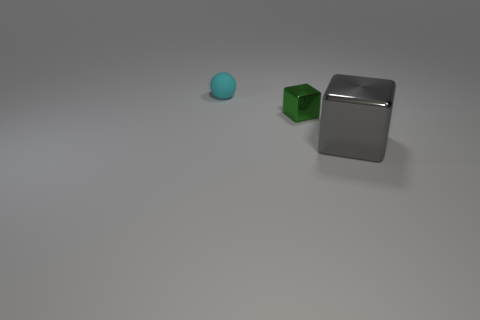Add 1 red rubber cubes. How many objects exist? 4 Add 1 gray shiny things. How many gray shiny things are left? 2 Add 3 large red rubber cylinders. How many large red rubber cylinders exist? 3 Subtract all gray cubes. How many cubes are left? 1 Subtract 0 brown balls. How many objects are left? 3 Subtract all blocks. How many objects are left? 1 Subtract 1 spheres. How many spheres are left? 0 Subtract all gray spheres. Subtract all yellow cylinders. How many spheres are left? 1 Subtract all yellow spheres. How many cyan blocks are left? 0 Subtract all tiny yellow rubber objects. Subtract all small metallic things. How many objects are left? 2 